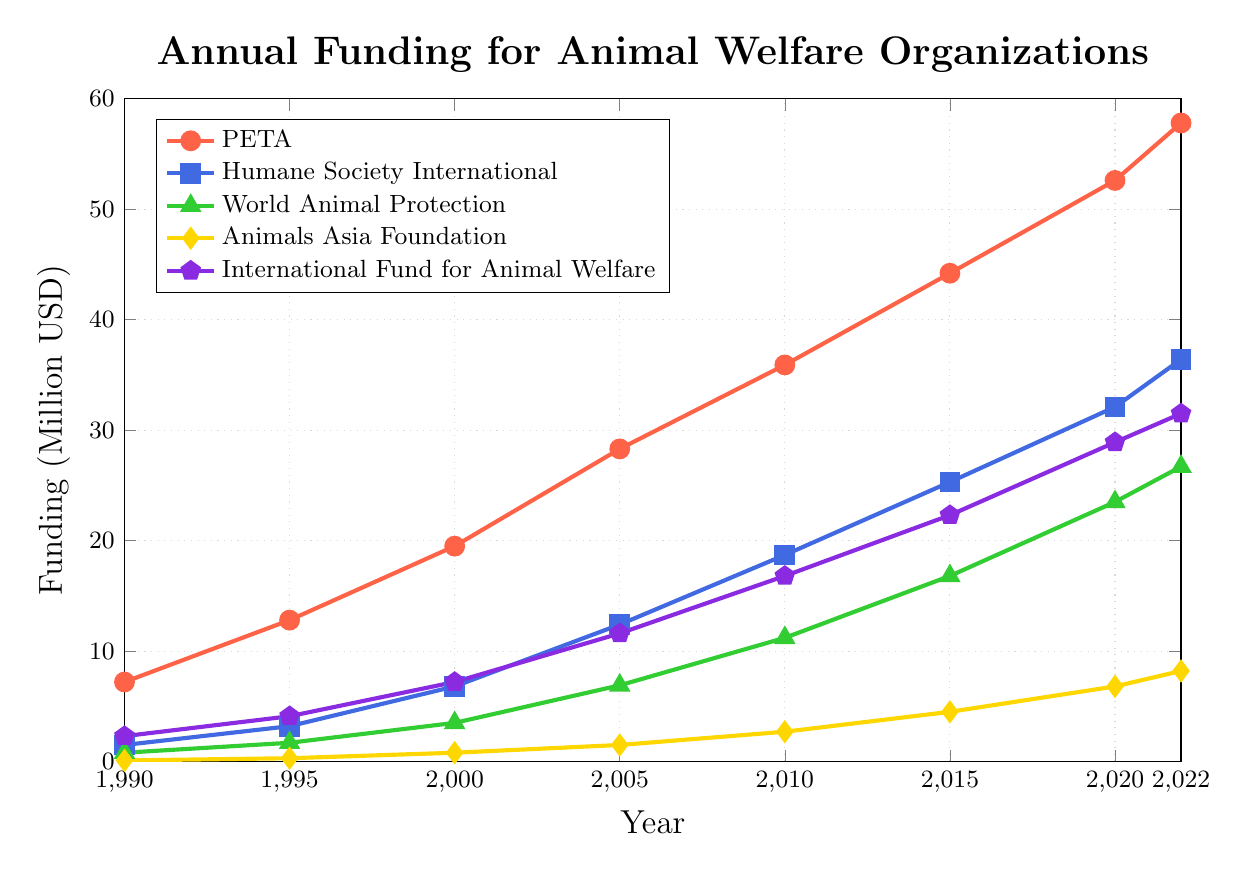What year did PETA's annual funding first exceed $50 million? PETA's annual funding can be tracked along its line plot. PETA first exceeded $50 million in 2020.
Answer: 2020 By how much did funding for World Animal Protection increase from 1990 to 2022? To find the increase, subtract the 1990 funding from the 2022 funding. The funding increased from $0.8 million to $26.7 million, which gives an increase of $26.7 million - $0.8 million = $25.9 million.
Answer: $25.9 million Which organization had the highest annual funding in 2022? Compare the 2022 funding values for all organizations. PETA had the highest annual funding at $57.8 million.
Answer: PETA How much more funding did the Humane Society International receive compared to the Animals Asia Foundation in 2022? Subtract the funding for Animals Asia Foundation from the Humane Society International's funding in 2022. The funding difference is $36.4 million - $8.2 million = $28.2 million.
Answer: $28.2 million Between which consecutive years did International Fund for Animal Welfare see the largest increase in funding? Calculate the funding increase for each consecutive period and find the largest. The increases are: (1995-1990), (2000-1995), (2005-2000), (2010-2005), (2015-2010), (2020-2015), and (2022-2020). The largest increase is between 2020 and 2022 with an increase of $31.5 million - $28.9 million = $2.6 million.
Answer: Between 2015 and 2020 What's the average annual funding for Animals Asia Foundation from 1990 to 2022? Sum the annual funding for Animals Asia Foundation over the years and divide by the number of data points. The sum is $0.1 + $0.3 + $0.8 + $1.5 + $2.7 + $4.5 + $6.8 + $8.2 = $24.9 million, and there are 8 data points, so the average is $24.9 million / 8 = $3.1 million.
Answer: $3.1 million What is the total funding for all organizations in 1990? Sum the funding for all organizations in 1990. The total is $7.2 million + $1.5 million + $0.8 million + $0.1 million + $2.3 million = $11.9 million.
Answer: $11.9 million Compare the rate of increase in funding between PETA and World Animal Protection from 2005 to 2010. Which organization had a higher rate of increase? Calculate the rate of increase for each: PETA's increase is from $28.3 million to $35.9 million, an increase of $35.9 million - $28.3 million = $7.6 million. World Animal Protection's increase is from $6.9 million to $11.2 million, an increase of $11.2 million - $6.9 million = $4.3 million. Compare the rates of increase: PETA's $7.6 million vs. World Animal Protection's $4.3 million.
Answer: PETA Which organization had the least amount of funding in 2000? Look at the data points for 2000. Animals Asia Foundation had the least amount with $0.8 million.
Answer: Animals Asia Foundation 